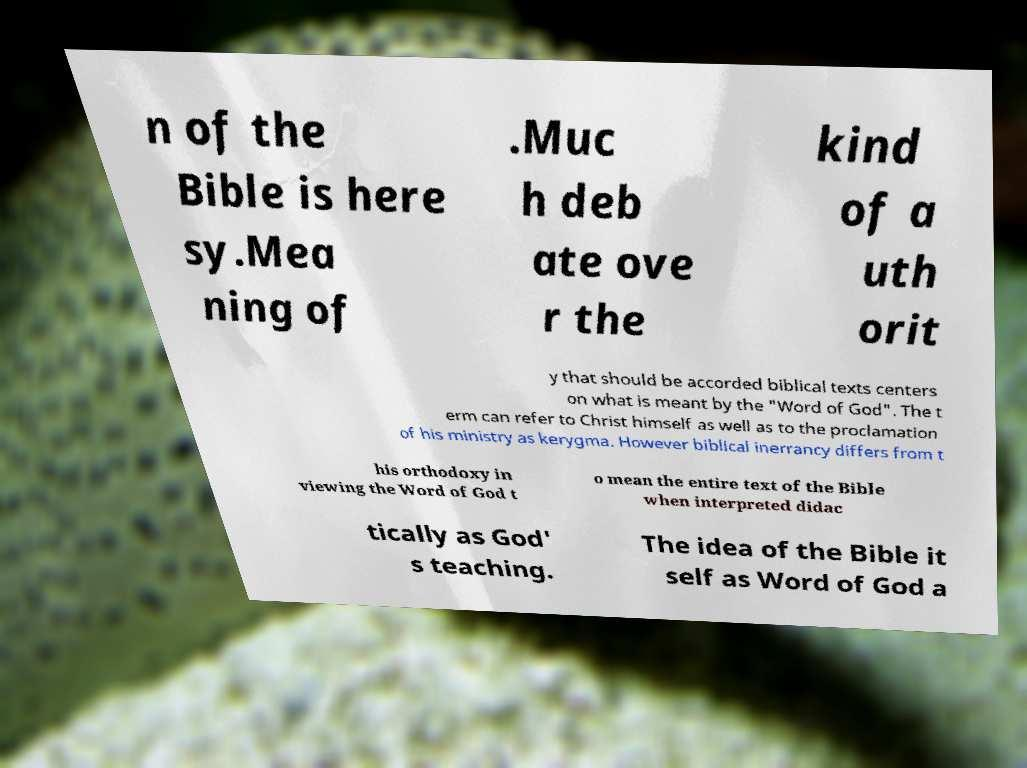Please read and relay the text visible in this image. What does it say? n of the Bible is here sy.Mea ning of .Muc h deb ate ove r the kind of a uth orit y that should be accorded biblical texts centers on what is meant by the "Word of God". The t erm can refer to Christ himself as well as to the proclamation of his ministry as kerygma. However biblical inerrancy differs from t his orthodoxy in viewing the Word of God t o mean the entire text of the Bible when interpreted didac tically as God' s teaching. The idea of the Bible it self as Word of God a 